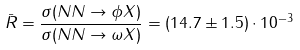Convert formula to latex. <formula><loc_0><loc_0><loc_500><loc_500>\bar { R } = \frac { \sigma ( N N \to \phi X ) } { \sigma ( N N \to \omega X ) } = ( 1 4 . 7 \pm 1 . 5 ) \cdot 1 0 ^ { - 3 }</formula> 